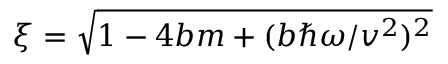<formula> <loc_0><loc_0><loc_500><loc_500>\xi = \sqrt { 1 - 4 b m + ( b \hbar { \omega } / v ^ { 2 } ) ^ { 2 } }</formula> 